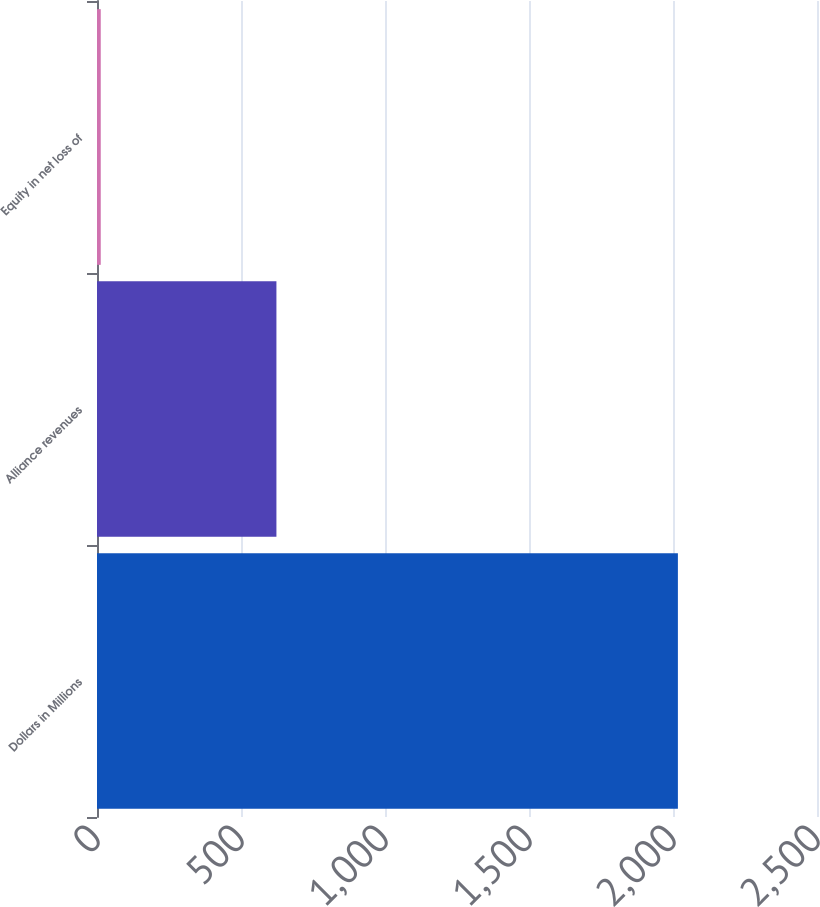<chart> <loc_0><loc_0><loc_500><loc_500><bar_chart><fcel>Dollars in Millions<fcel>Alliance revenues<fcel>Equity in net loss of<nl><fcel>2017<fcel>623<fcel>13<nl></chart> 